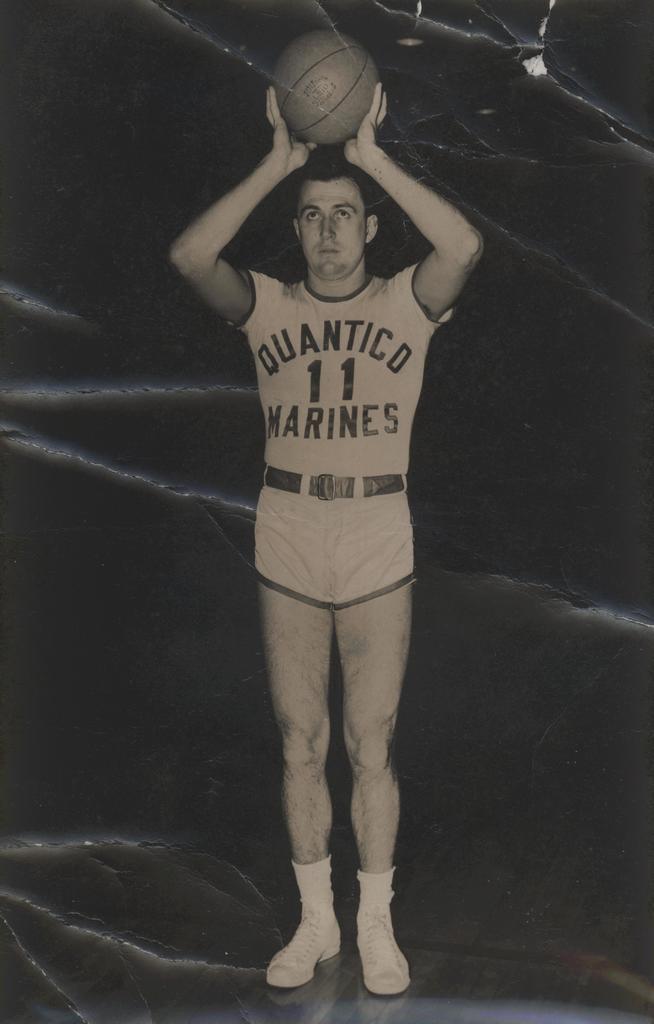What team does this man play for?
Provide a short and direct response. Quantico marines. 